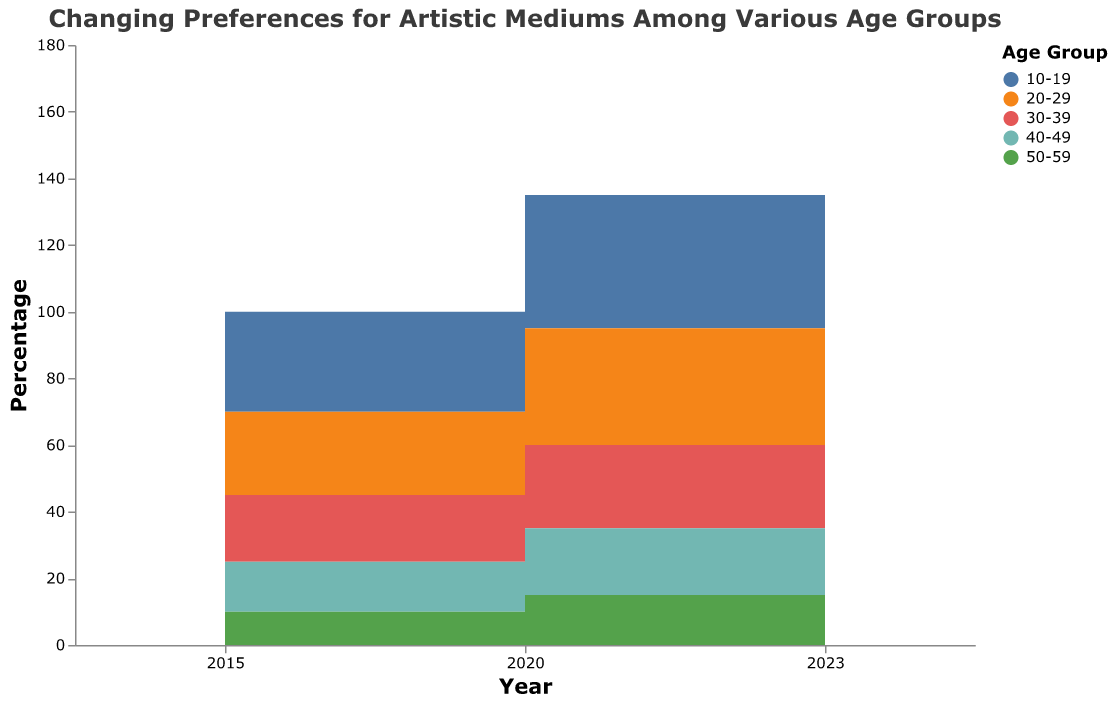What is the title of the figure? The title is located at the top of the figure and is usually in a larger font size compared to other text elements.
Answer: Changing Preferences for Artistic Mediums Among Various Age Groups Which age group had the highest preference for Digital Art in 2023? Look at the colors representing each age group in the legend and then find the color with the highest point on Digital Art for the year 2023.
Answer: 10-19 How did the preference for Graphic Novels change for the 20-29 age group from 2015 to 2023? Locate the color representing the 20-29 age group in the legend and follow it across the years 2015, 2020, and 2023. Note the values for Graphic Novels and observe the trend.
Answer: Increased Which age group showed the greatest decrease in preference for Traditional Painting from 2015 to 2023? Identify each age group color in the legend, then observe the values for Traditional Painting in 2015 and 2023 for each group and find the one with the greatest decrease by calculating the differences.
Answer: 50-59 Compare the preferences for Photography and Sculpture for the 30-39 age group in 2023. Which was higher? First, find the color that represents the 30-39 age group. Then compare the values of Photography and Sculpture for this group in 2023.
Answer: Photography What was the combined percentage of Digital Art and Graphic Novels for the 10-19 age group in 2023? Look at the values for Digital Art and Graphic Novels for the 10-19 age group in 2023. Sum these values to find the total percentage.
Answer: 78 Which artistic medium experienced the most consistent decrease in preference across all age groups from 2015 to 2023? Examine each medium across all the age groups and years. Identify the medium that consistently shows a decreasing trend.
Answer: Traditional Painting For the 40-49 age group, in which year was the preference for Sculpture at its peak? Look at the values for Sculpture for the 40-49 age group for each year. Determine the year with the highest value.
Answer: 2015 In 2020, which age group had the lowest preference for Digital Art? Find the values for Digital Art in 2020 for each age group and identify the one with the lowest value.
Answer: 50-59 How does the trend in preferences for Digital Art differ between the 10-19 and 50-59 age groups from 2015 to 2023? Compare the change in values for Digital Art from 2015 to 2023 between the 10-19 and 50-59 age groups. Note whether each group’s preference increased or decreased and the magnitude of the change.
Answer: 10-19 increased significantly, 50-59 increased moderately 